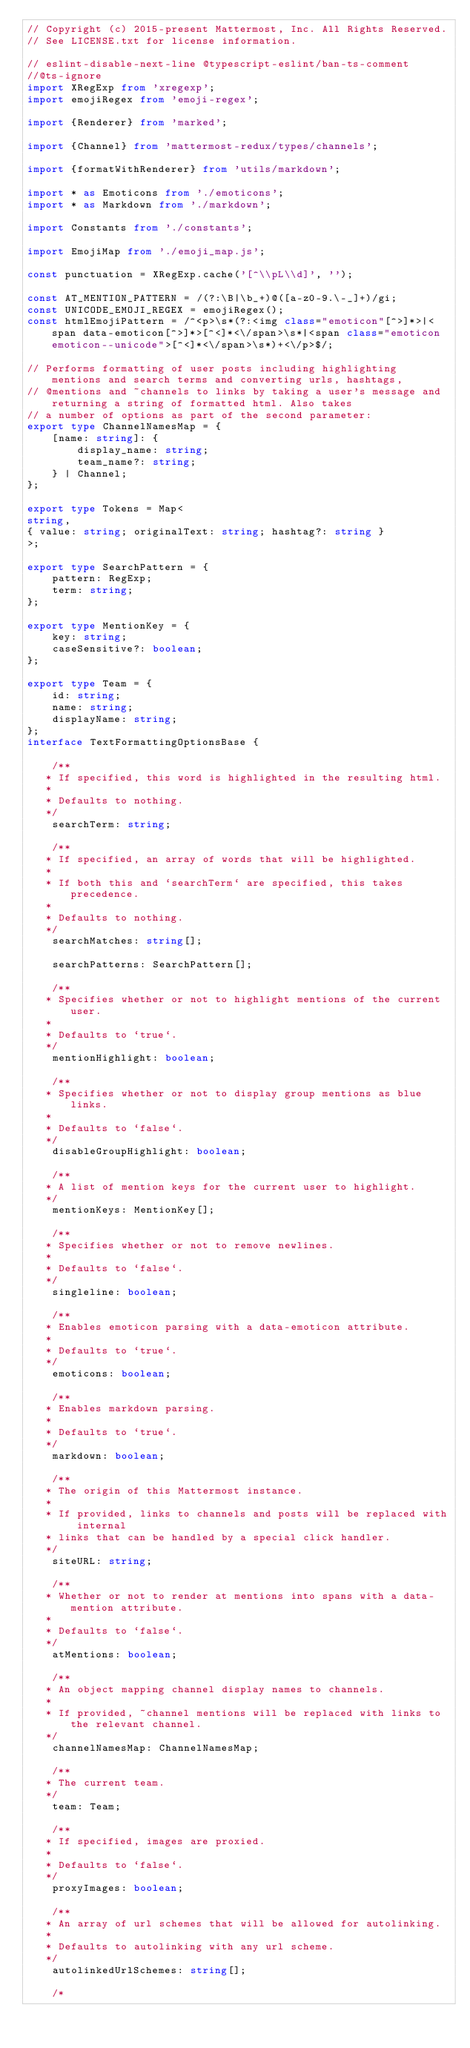Convert code to text. <code><loc_0><loc_0><loc_500><loc_500><_TypeScript_>// Copyright (c) 2015-present Mattermost, Inc. All Rights Reserved.
// See LICENSE.txt for license information.

// eslint-disable-next-line @typescript-eslint/ban-ts-comment
//@ts-ignore
import XRegExp from 'xregexp';
import emojiRegex from 'emoji-regex';

import {Renderer} from 'marked';

import {Channel} from 'mattermost-redux/types/channels';

import {formatWithRenderer} from 'utils/markdown';

import * as Emoticons from './emoticons';
import * as Markdown from './markdown';

import Constants from './constants';

import EmojiMap from './emoji_map.js';

const punctuation = XRegExp.cache('[^\\pL\\d]', '');

const AT_MENTION_PATTERN = /(?:\B|\b_+)@([a-z0-9.\-_]+)/gi;
const UNICODE_EMOJI_REGEX = emojiRegex();
const htmlEmojiPattern = /^<p>\s*(?:<img class="emoticon"[^>]*>|<span data-emoticon[^>]*>[^<]*<\/span>\s*|<span class="emoticon emoticon--unicode">[^<]*<\/span>\s*)+<\/p>$/;

// Performs formatting of user posts including highlighting mentions and search terms and converting urls, hashtags,
// @mentions and ~channels to links by taking a user's message and returning a string of formatted html. Also takes
// a number of options as part of the second parameter:
export type ChannelNamesMap = {
    [name: string]: {
        display_name: string;
        team_name?: string;
    } | Channel;
};

export type Tokens = Map<
string,
{ value: string; originalText: string; hashtag?: string }
>;

export type SearchPattern = {
    pattern: RegExp;
    term: string;
};

export type MentionKey = {
    key: string;
    caseSensitive?: boolean;
};

export type Team = {
    id: string;
    name: string;
    displayName: string;
};
interface TextFormattingOptionsBase {

    /**
   * If specified, this word is highlighted in the resulting html.
   *
   * Defaults to nothing.
   */
    searchTerm: string;

    /**
   * If specified, an array of words that will be highlighted.
   *
   * If both this and `searchTerm` are specified, this takes precedence.
   *
   * Defaults to nothing.
   */
    searchMatches: string[];

    searchPatterns: SearchPattern[];

    /**
   * Specifies whether or not to highlight mentions of the current user.
   *
   * Defaults to `true`.
   */
    mentionHighlight: boolean;

    /**
   * Specifies whether or not to display group mentions as blue links.
   *
   * Defaults to `false`.
   */
    disableGroupHighlight: boolean;

    /**
   * A list of mention keys for the current user to highlight.
   */
    mentionKeys: MentionKey[];

    /**
   * Specifies whether or not to remove newlines.
   *
   * Defaults to `false`.
   */
    singleline: boolean;

    /**
   * Enables emoticon parsing with a data-emoticon attribute.
   *
   * Defaults to `true`.
   */
    emoticons: boolean;

    /**
   * Enables markdown parsing.
   *
   * Defaults to `true`.
   */
    markdown: boolean;

    /**
   * The origin of this Mattermost instance.
   *
   * If provided, links to channels and posts will be replaced with internal
   * links that can be handled by a special click handler.
   */
    siteURL: string;

    /**
   * Whether or not to render at mentions into spans with a data-mention attribute.
   *
   * Defaults to `false`.
   */
    atMentions: boolean;

    /**
   * An object mapping channel display names to channels.
   *
   * If provided, ~channel mentions will be replaced with links to the relevant channel.
   */
    channelNamesMap: ChannelNamesMap;

    /**
   * The current team.
   */
    team: Team;

    /**
   * If specified, images are proxied.
   *
   * Defaults to `false`.
   */
    proxyImages: boolean;

    /**
   * An array of url schemes that will be allowed for autolinking.
   *
   * Defaults to autolinking with any url scheme.
   */
    autolinkedUrlSchemes: string[];

    /*</code> 